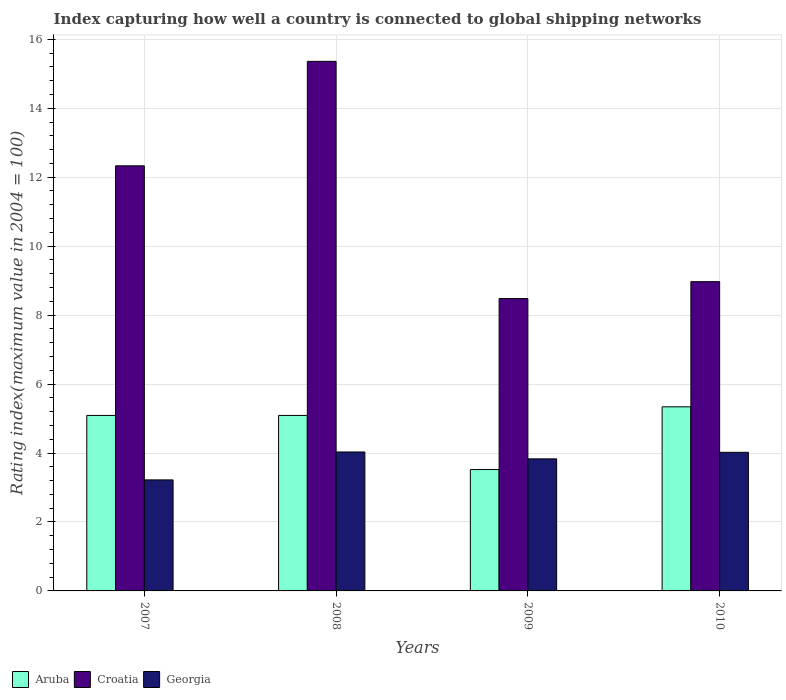How many bars are there on the 4th tick from the right?
Give a very brief answer. 3. In how many cases, is the number of bars for a given year not equal to the number of legend labels?
Your response must be concise. 0. What is the rating index in Croatia in 2008?
Keep it short and to the point. 15.36. Across all years, what is the maximum rating index in Croatia?
Make the answer very short. 15.36. Across all years, what is the minimum rating index in Croatia?
Keep it short and to the point. 8.48. What is the total rating index in Aruba in the graph?
Offer a very short reply. 19.04. What is the difference between the rating index in Croatia in 2008 and that in 2009?
Give a very brief answer. 6.88. What is the difference between the rating index in Aruba in 2010 and the rating index in Georgia in 2009?
Offer a very short reply. 1.51. What is the average rating index in Aruba per year?
Offer a very short reply. 4.76. In the year 2007, what is the difference between the rating index in Croatia and rating index in Georgia?
Your answer should be compact. 9.11. What is the ratio of the rating index in Croatia in 2007 to that in 2010?
Offer a very short reply. 1.37. Is the rating index in Georgia in 2008 less than that in 2009?
Provide a short and direct response. No. What is the difference between the highest and the lowest rating index in Georgia?
Ensure brevity in your answer.  0.81. Is the sum of the rating index in Aruba in 2007 and 2010 greater than the maximum rating index in Georgia across all years?
Provide a short and direct response. Yes. What does the 3rd bar from the left in 2010 represents?
Your response must be concise. Georgia. What does the 1st bar from the right in 2007 represents?
Your response must be concise. Georgia. Is it the case that in every year, the sum of the rating index in Georgia and rating index in Aruba is greater than the rating index in Croatia?
Provide a succinct answer. No. Are all the bars in the graph horizontal?
Provide a short and direct response. No. How many years are there in the graph?
Your answer should be compact. 4. Where does the legend appear in the graph?
Offer a terse response. Bottom left. What is the title of the graph?
Offer a terse response. Index capturing how well a country is connected to global shipping networks. Does "Belgium" appear as one of the legend labels in the graph?
Your answer should be compact. No. What is the label or title of the X-axis?
Make the answer very short. Years. What is the label or title of the Y-axis?
Offer a terse response. Rating index(maximum value in 2004 = 100). What is the Rating index(maximum value in 2004 = 100) of Aruba in 2007?
Your answer should be compact. 5.09. What is the Rating index(maximum value in 2004 = 100) of Croatia in 2007?
Offer a terse response. 12.33. What is the Rating index(maximum value in 2004 = 100) of Georgia in 2007?
Your answer should be compact. 3.22. What is the Rating index(maximum value in 2004 = 100) in Aruba in 2008?
Give a very brief answer. 5.09. What is the Rating index(maximum value in 2004 = 100) in Croatia in 2008?
Your answer should be very brief. 15.36. What is the Rating index(maximum value in 2004 = 100) of Georgia in 2008?
Offer a very short reply. 4.03. What is the Rating index(maximum value in 2004 = 100) of Aruba in 2009?
Your answer should be compact. 3.52. What is the Rating index(maximum value in 2004 = 100) in Croatia in 2009?
Keep it short and to the point. 8.48. What is the Rating index(maximum value in 2004 = 100) in Georgia in 2009?
Make the answer very short. 3.83. What is the Rating index(maximum value in 2004 = 100) in Aruba in 2010?
Ensure brevity in your answer.  5.34. What is the Rating index(maximum value in 2004 = 100) of Croatia in 2010?
Give a very brief answer. 8.97. What is the Rating index(maximum value in 2004 = 100) of Georgia in 2010?
Your response must be concise. 4.02. Across all years, what is the maximum Rating index(maximum value in 2004 = 100) of Aruba?
Your response must be concise. 5.34. Across all years, what is the maximum Rating index(maximum value in 2004 = 100) of Croatia?
Offer a terse response. 15.36. Across all years, what is the maximum Rating index(maximum value in 2004 = 100) of Georgia?
Ensure brevity in your answer.  4.03. Across all years, what is the minimum Rating index(maximum value in 2004 = 100) of Aruba?
Keep it short and to the point. 3.52. Across all years, what is the minimum Rating index(maximum value in 2004 = 100) in Croatia?
Provide a short and direct response. 8.48. Across all years, what is the minimum Rating index(maximum value in 2004 = 100) of Georgia?
Make the answer very short. 3.22. What is the total Rating index(maximum value in 2004 = 100) in Aruba in the graph?
Offer a terse response. 19.04. What is the total Rating index(maximum value in 2004 = 100) of Croatia in the graph?
Ensure brevity in your answer.  45.14. What is the difference between the Rating index(maximum value in 2004 = 100) in Aruba in 2007 and that in 2008?
Offer a very short reply. 0. What is the difference between the Rating index(maximum value in 2004 = 100) in Croatia in 2007 and that in 2008?
Offer a terse response. -3.03. What is the difference between the Rating index(maximum value in 2004 = 100) in Georgia in 2007 and that in 2008?
Offer a very short reply. -0.81. What is the difference between the Rating index(maximum value in 2004 = 100) of Aruba in 2007 and that in 2009?
Provide a succinct answer. 1.57. What is the difference between the Rating index(maximum value in 2004 = 100) in Croatia in 2007 and that in 2009?
Keep it short and to the point. 3.85. What is the difference between the Rating index(maximum value in 2004 = 100) in Georgia in 2007 and that in 2009?
Ensure brevity in your answer.  -0.61. What is the difference between the Rating index(maximum value in 2004 = 100) of Croatia in 2007 and that in 2010?
Offer a very short reply. 3.36. What is the difference between the Rating index(maximum value in 2004 = 100) in Aruba in 2008 and that in 2009?
Your answer should be compact. 1.57. What is the difference between the Rating index(maximum value in 2004 = 100) in Croatia in 2008 and that in 2009?
Keep it short and to the point. 6.88. What is the difference between the Rating index(maximum value in 2004 = 100) in Croatia in 2008 and that in 2010?
Your answer should be compact. 6.39. What is the difference between the Rating index(maximum value in 2004 = 100) in Georgia in 2008 and that in 2010?
Ensure brevity in your answer.  0.01. What is the difference between the Rating index(maximum value in 2004 = 100) of Aruba in 2009 and that in 2010?
Ensure brevity in your answer.  -1.82. What is the difference between the Rating index(maximum value in 2004 = 100) in Croatia in 2009 and that in 2010?
Keep it short and to the point. -0.49. What is the difference between the Rating index(maximum value in 2004 = 100) in Georgia in 2009 and that in 2010?
Keep it short and to the point. -0.19. What is the difference between the Rating index(maximum value in 2004 = 100) of Aruba in 2007 and the Rating index(maximum value in 2004 = 100) of Croatia in 2008?
Provide a succinct answer. -10.27. What is the difference between the Rating index(maximum value in 2004 = 100) of Aruba in 2007 and the Rating index(maximum value in 2004 = 100) of Georgia in 2008?
Offer a very short reply. 1.06. What is the difference between the Rating index(maximum value in 2004 = 100) of Croatia in 2007 and the Rating index(maximum value in 2004 = 100) of Georgia in 2008?
Make the answer very short. 8.3. What is the difference between the Rating index(maximum value in 2004 = 100) of Aruba in 2007 and the Rating index(maximum value in 2004 = 100) of Croatia in 2009?
Your response must be concise. -3.39. What is the difference between the Rating index(maximum value in 2004 = 100) of Aruba in 2007 and the Rating index(maximum value in 2004 = 100) of Georgia in 2009?
Keep it short and to the point. 1.26. What is the difference between the Rating index(maximum value in 2004 = 100) of Croatia in 2007 and the Rating index(maximum value in 2004 = 100) of Georgia in 2009?
Offer a terse response. 8.5. What is the difference between the Rating index(maximum value in 2004 = 100) in Aruba in 2007 and the Rating index(maximum value in 2004 = 100) in Croatia in 2010?
Give a very brief answer. -3.88. What is the difference between the Rating index(maximum value in 2004 = 100) in Aruba in 2007 and the Rating index(maximum value in 2004 = 100) in Georgia in 2010?
Provide a succinct answer. 1.07. What is the difference between the Rating index(maximum value in 2004 = 100) in Croatia in 2007 and the Rating index(maximum value in 2004 = 100) in Georgia in 2010?
Your answer should be very brief. 8.31. What is the difference between the Rating index(maximum value in 2004 = 100) of Aruba in 2008 and the Rating index(maximum value in 2004 = 100) of Croatia in 2009?
Make the answer very short. -3.39. What is the difference between the Rating index(maximum value in 2004 = 100) of Aruba in 2008 and the Rating index(maximum value in 2004 = 100) of Georgia in 2009?
Keep it short and to the point. 1.26. What is the difference between the Rating index(maximum value in 2004 = 100) of Croatia in 2008 and the Rating index(maximum value in 2004 = 100) of Georgia in 2009?
Your answer should be compact. 11.53. What is the difference between the Rating index(maximum value in 2004 = 100) in Aruba in 2008 and the Rating index(maximum value in 2004 = 100) in Croatia in 2010?
Provide a short and direct response. -3.88. What is the difference between the Rating index(maximum value in 2004 = 100) of Aruba in 2008 and the Rating index(maximum value in 2004 = 100) of Georgia in 2010?
Keep it short and to the point. 1.07. What is the difference between the Rating index(maximum value in 2004 = 100) in Croatia in 2008 and the Rating index(maximum value in 2004 = 100) in Georgia in 2010?
Give a very brief answer. 11.34. What is the difference between the Rating index(maximum value in 2004 = 100) of Aruba in 2009 and the Rating index(maximum value in 2004 = 100) of Croatia in 2010?
Offer a terse response. -5.45. What is the difference between the Rating index(maximum value in 2004 = 100) of Croatia in 2009 and the Rating index(maximum value in 2004 = 100) of Georgia in 2010?
Ensure brevity in your answer.  4.46. What is the average Rating index(maximum value in 2004 = 100) in Aruba per year?
Give a very brief answer. 4.76. What is the average Rating index(maximum value in 2004 = 100) of Croatia per year?
Your answer should be very brief. 11.29. What is the average Rating index(maximum value in 2004 = 100) of Georgia per year?
Your answer should be very brief. 3.77. In the year 2007, what is the difference between the Rating index(maximum value in 2004 = 100) in Aruba and Rating index(maximum value in 2004 = 100) in Croatia?
Offer a very short reply. -7.24. In the year 2007, what is the difference between the Rating index(maximum value in 2004 = 100) of Aruba and Rating index(maximum value in 2004 = 100) of Georgia?
Provide a short and direct response. 1.87. In the year 2007, what is the difference between the Rating index(maximum value in 2004 = 100) of Croatia and Rating index(maximum value in 2004 = 100) of Georgia?
Your answer should be compact. 9.11. In the year 2008, what is the difference between the Rating index(maximum value in 2004 = 100) of Aruba and Rating index(maximum value in 2004 = 100) of Croatia?
Offer a terse response. -10.27. In the year 2008, what is the difference between the Rating index(maximum value in 2004 = 100) in Aruba and Rating index(maximum value in 2004 = 100) in Georgia?
Provide a succinct answer. 1.06. In the year 2008, what is the difference between the Rating index(maximum value in 2004 = 100) in Croatia and Rating index(maximum value in 2004 = 100) in Georgia?
Keep it short and to the point. 11.33. In the year 2009, what is the difference between the Rating index(maximum value in 2004 = 100) in Aruba and Rating index(maximum value in 2004 = 100) in Croatia?
Keep it short and to the point. -4.96. In the year 2009, what is the difference between the Rating index(maximum value in 2004 = 100) in Aruba and Rating index(maximum value in 2004 = 100) in Georgia?
Your answer should be compact. -0.31. In the year 2009, what is the difference between the Rating index(maximum value in 2004 = 100) of Croatia and Rating index(maximum value in 2004 = 100) of Georgia?
Provide a succinct answer. 4.65. In the year 2010, what is the difference between the Rating index(maximum value in 2004 = 100) in Aruba and Rating index(maximum value in 2004 = 100) in Croatia?
Provide a short and direct response. -3.63. In the year 2010, what is the difference between the Rating index(maximum value in 2004 = 100) of Aruba and Rating index(maximum value in 2004 = 100) of Georgia?
Offer a terse response. 1.32. In the year 2010, what is the difference between the Rating index(maximum value in 2004 = 100) of Croatia and Rating index(maximum value in 2004 = 100) of Georgia?
Give a very brief answer. 4.95. What is the ratio of the Rating index(maximum value in 2004 = 100) of Croatia in 2007 to that in 2008?
Provide a succinct answer. 0.8. What is the ratio of the Rating index(maximum value in 2004 = 100) of Georgia in 2007 to that in 2008?
Give a very brief answer. 0.8. What is the ratio of the Rating index(maximum value in 2004 = 100) in Aruba in 2007 to that in 2009?
Keep it short and to the point. 1.45. What is the ratio of the Rating index(maximum value in 2004 = 100) of Croatia in 2007 to that in 2009?
Provide a short and direct response. 1.45. What is the ratio of the Rating index(maximum value in 2004 = 100) in Georgia in 2007 to that in 2009?
Provide a succinct answer. 0.84. What is the ratio of the Rating index(maximum value in 2004 = 100) of Aruba in 2007 to that in 2010?
Provide a succinct answer. 0.95. What is the ratio of the Rating index(maximum value in 2004 = 100) of Croatia in 2007 to that in 2010?
Make the answer very short. 1.37. What is the ratio of the Rating index(maximum value in 2004 = 100) of Georgia in 2007 to that in 2010?
Provide a short and direct response. 0.8. What is the ratio of the Rating index(maximum value in 2004 = 100) of Aruba in 2008 to that in 2009?
Ensure brevity in your answer.  1.45. What is the ratio of the Rating index(maximum value in 2004 = 100) of Croatia in 2008 to that in 2009?
Your answer should be very brief. 1.81. What is the ratio of the Rating index(maximum value in 2004 = 100) in Georgia in 2008 to that in 2009?
Ensure brevity in your answer.  1.05. What is the ratio of the Rating index(maximum value in 2004 = 100) of Aruba in 2008 to that in 2010?
Your response must be concise. 0.95. What is the ratio of the Rating index(maximum value in 2004 = 100) of Croatia in 2008 to that in 2010?
Keep it short and to the point. 1.71. What is the ratio of the Rating index(maximum value in 2004 = 100) in Georgia in 2008 to that in 2010?
Ensure brevity in your answer.  1. What is the ratio of the Rating index(maximum value in 2004 = 100) in Aruba in 2009 to that in 2010?
Keep it short and to the point. 0.66. What is the ratio of the Rating index(maximum value in 2004 = 100) in Croatia in 2009 to that in 2010?
Offer a terse response. 0.95. What is the ratio of the Rating index(maximum value in 2004 = 100) of Georgia in 2009 to that in 2010?
Your response must be concise. 0.95. What is the difference between the highest and the second highest Rating index(maximum value in 2004 = 100) of Aruba?
Give a very brief answer. 0.25. What is the difference between the highest and the second highest Rating index(maximum value in 2004 = 100) in Croatia?
Provide a short and direct response. 3.03. What is the difference between the highest and the lowest Rating index(maximum value in 2004 = 100) in Aruba?
Keep it short and to the point. 1.82. What is the difference between the highest and the lowest Rating index(maximum value in 2004 = 100) in Croatia?
Your answer should be very brief. 6.88. What is the difference between the highest and the lowest Rating index(maximum value in 2004 = 100) of Georgia?
Make the answer very short. 0.81. 